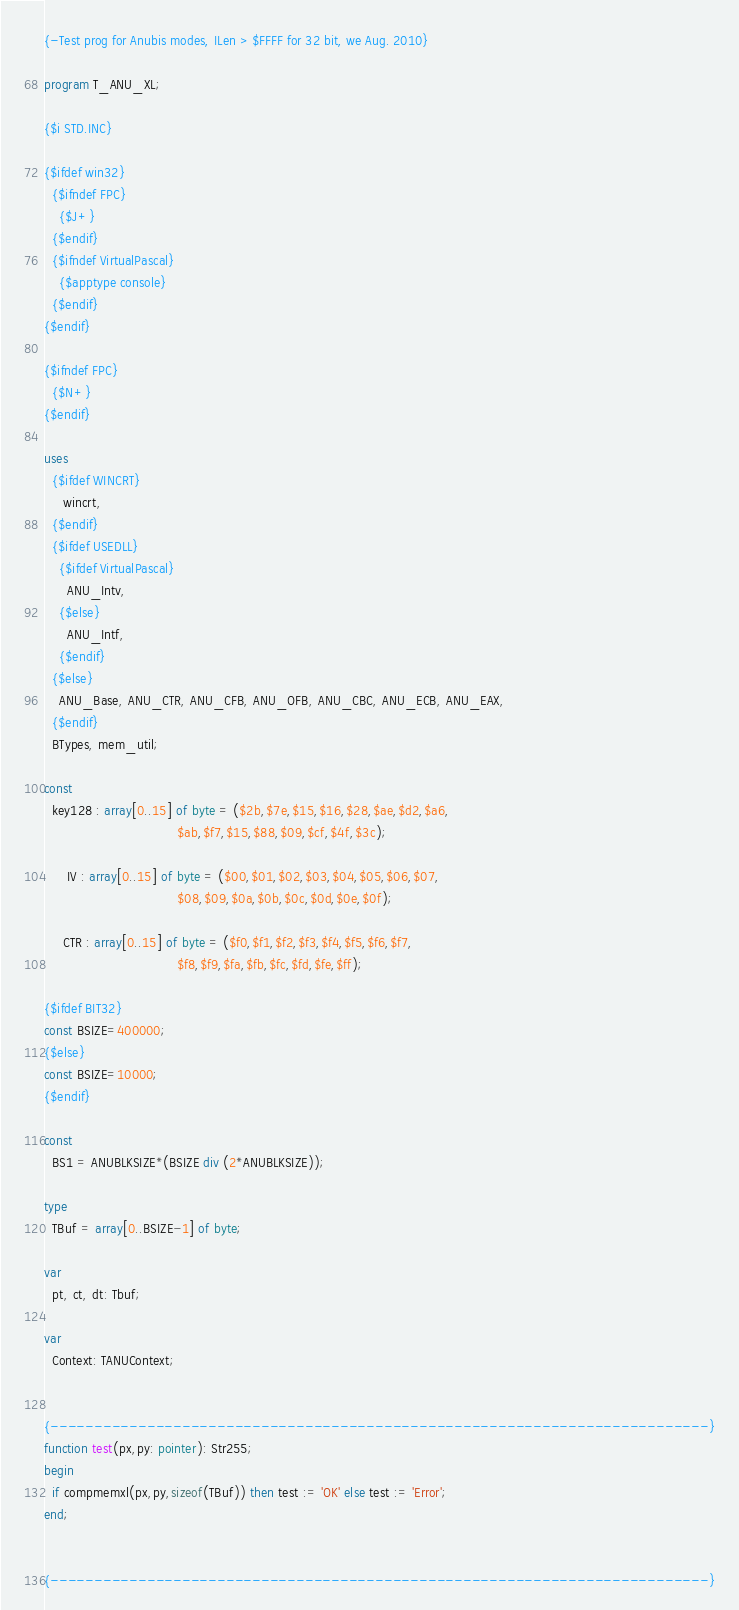<code> <loc_0><loc_0><loc_500><loc_500><_Pascal_>{-Test prog for Anubis modes, ILen > $FFFF for 32 bit, we Aug. 2010}

program T_ANU_XL;

{$i STD.INC}

{$ifdef win32}
  {$ifndef FPC}
    {$J+}
  {$endif}
  {$ifndef VirtualPascal}
    {$apptype console}
  {$endif}
{$endif}

{$ifndef FPC}
  {$N+}
{$endif}

uses
  {$ifdef WINCRT}
     wincrt,
  {$endif}
  {$ifdef USEDLL}
    {$ifdef VirtualPascal}
      ANU_Intv,
    {$else}
      ANU_Intf,
    {$endif}
  {$else}
    ANU_Base, ANU_CTR, ANU_CFB, ANU_OFB, ANU_CBC, ANU_ECB, ANU_EAX,
  {$endif}
  BTypes, mem_util;

const
  key128 : array[0..15] of byte = ($2b,$7e,$15,$16,$28,$ae,$d2,$a6,
                                   $ab,$f7,$15,$88,$09,$cf,$4f,$3c);

      IV : array[0..15] of byte = ($00,$01,$02,$03,$04,$05,$06,$07,
                                   $08,$09,$0a,$0b,$0c,$0d,$0e,$0f);

     CTR : array[0..15] of byte = ($f0,$f1,$f2,$f3,$f4,$f5,$f6,$f7,
                                   $f8,$f9,$fa,$fb,$fc,$fd,$fe,$ff);

{$ifdef BIT32}
const BSIZE=400000;
{$else}
const BSIZE=10000;
{$endif}

const
  BS1 = ANUBLKSIZE*(BSIZE div (2*ANUBLKSIZE));

type
  TBuf = array[0..BSIZE-1] of byte;

var
  pt, ct, dt: Tbuf;

var
  Context: TANUContext;


{---------------------------------------------------------------------------}
function test(px,py: pointer): Str255;
begin
  if compmemxl(px,py,sizeof(TBuf)) then test := 'OK' else test := 'Error';
end;


{---------------------------------------------------------------------------}</code> 